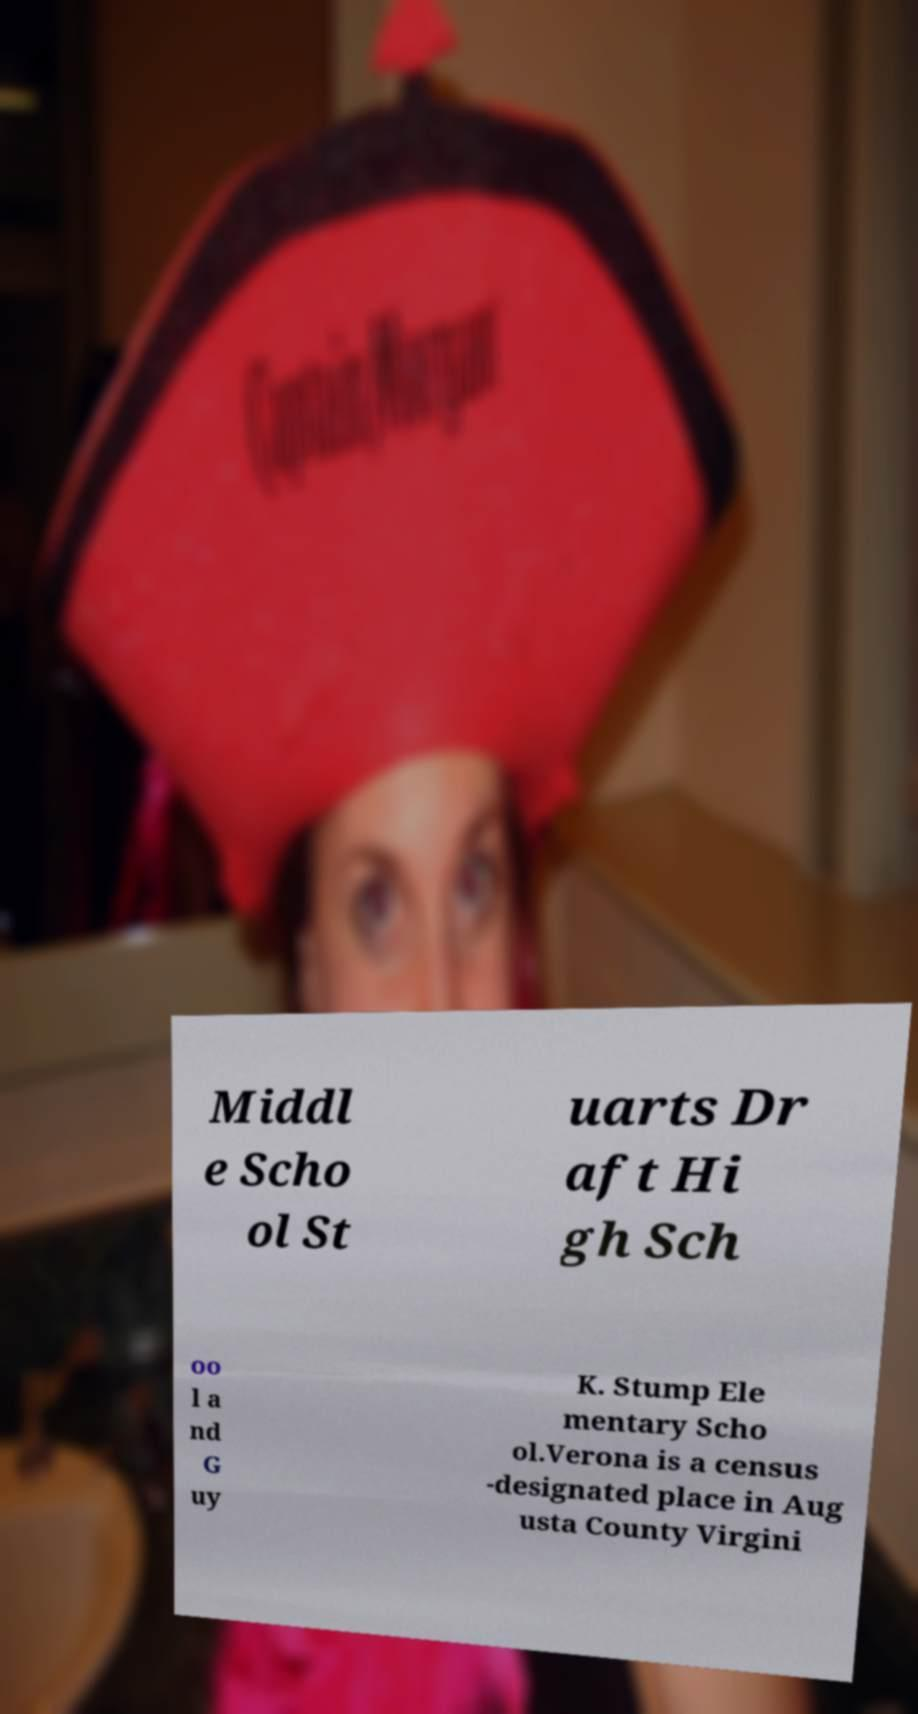Can you accurately transcribe the text from the provided image for me? Middl e Scho ol St uarts Dr aft Hi gh Sch oo l a nd G uy K. Stump Ele mentary Scho ol.Verona is a census -designated place in Aug usta County Virgini 